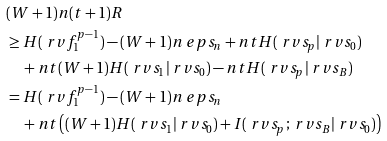<formula> <loc_0><loc_0><loc_500><loc_500>& ( W + 1 ) n ( t + 1 ) R \\ & \geq H ( \ r v f _ { 1 } ^ { p - 1 } ) - ( W + 1 ) n \ e p s _ { n } + n t H ( \ r v s _ { p } | \ r v s _ { 0 } ) \\ & \quad + n t ( W + 1 ) H ( \ r v s _ { 1 } | \ r v s _ { 0 } ) - n t H ( \ r v s _ { p } | \ r v s _ { B } ) \\ & = H ( \ r v f _ { 1 } ^ { p - 1 } ) - ( W + 1 ) n \ e p s _ { n } \\ & \quad + n t \left ( ( W + 1 ) H ( \ r v s _ { 1 } | \ r v s _ { 0 } ) + I ( \ r v s _ { p } ; \ r v s _ { B } | \ r v s _ { 0 } ) \right )</formula> 